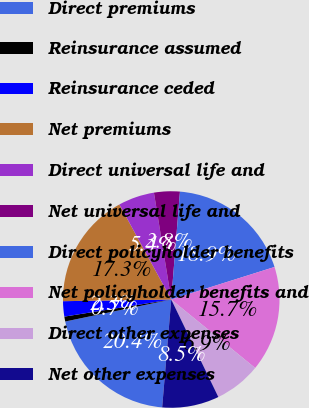Convert chart. <chart><loc_0><loc_0><loc_500><loc_500><pie_chart><fcel>Direct premiums<fcel>Reinsurance assumed<fcel>Reinsurance ceded<fcel>Net premiums<fcel>Direct universal life and<fcel>Net universal life and<fcel>Direct policyholder benefits<fcel>Net policyholder benefits and<fcel>Direct other expenses<fcel>Net other expenses<nl><fcel>20.41%<fcel>0.73%<fcel>2.28%<fcel>17.3%<fcel>5.39%<fcel>3.84%<fcel>18.86%<fcel>15.75%<fcel>6.95%<fcel>8.5%<nl></chart> 